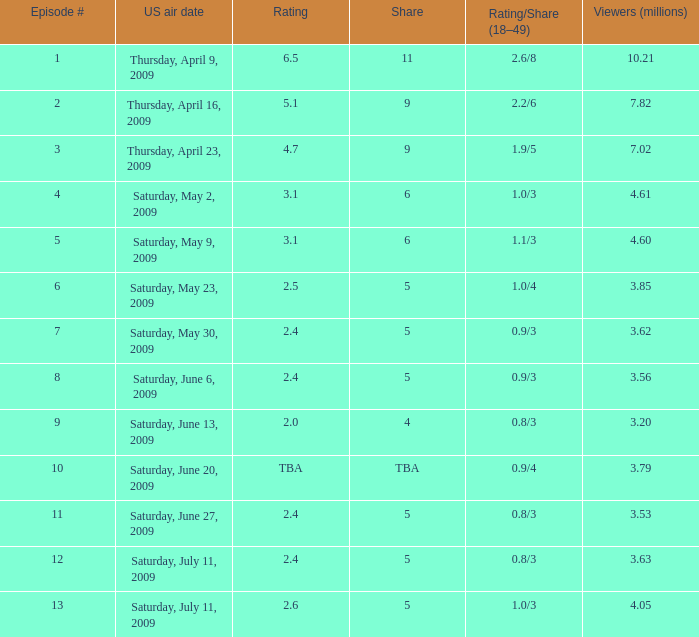What is the rating/share for episode 13? 1.0/3. Could you help me parse every detail presented in this table? {'header': ['Episode #', 'US air date', 'Rating', 'Share', 'Rating/Share (18–49)', 'Viewers (millions)'], 'rows': [['1', 'Thursday, April 9, 2009', '6.5', '11', '2.6/8', '10.21'], ['2', 'Thursday, April 16, 2009', '5.1', '9', '2.2/6', '7.82'], ['3', 'Thursday, April 23, 2009', '4.7', '9', '1.9/5', '7.02'], ['4', 'Saturday, May 2, 2009', '3.1', '6', '1.0/3', '4.61'], ['5', 'Saturday, May 9, 2009', '3.1', '6', '1.1/3', '4.60'], ['6', 'Saturday, May 23, 2009', '2.5', '5', '1.0/4', '3.85'], ['7', 'Saturday, May 30, 2009', '2.4', '5', '0.9/3', '3.62'], ['8', 'Saturday, June 6, 2009', '2.4', '5', '0.9/3', '3.56'], ['9', 'Saturday, June 13, 2009', '2.0', '4', '0.8/3', '3.20'], ['10', 'Saturday, June 20, 2009', 'TBA', 'TBA', '0.9/4', '3.79'], ['11', 'Saturday, June 27, 2009', '2.4', '5', '0.8/3', '3.53'], ['12', 'Saturday, July 11, 2009', '2.4', '5', '0.8/3', '3.63'], ['13', 'Saturday, July 11, 2009', '2.6', '5', '1.0/3', '4.05']]} 